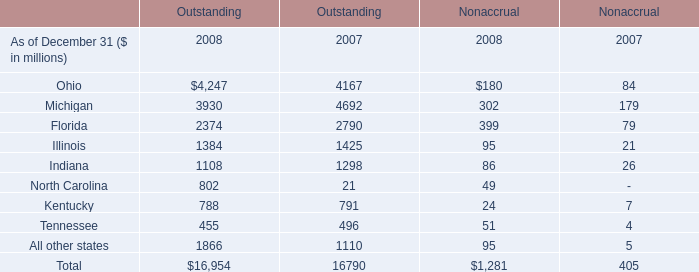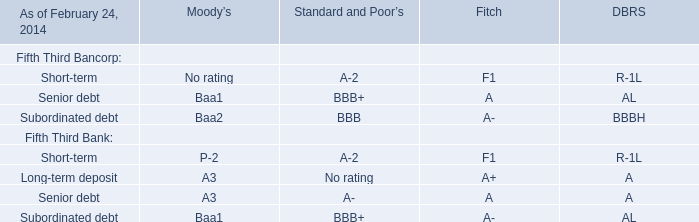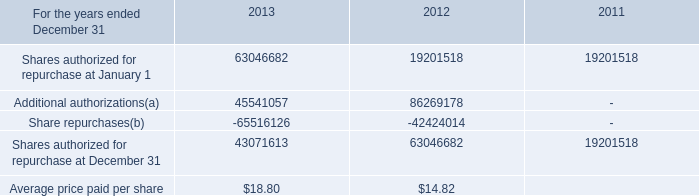Which year is the Outstanding of Michigan the least? 
Answer: 2008. 